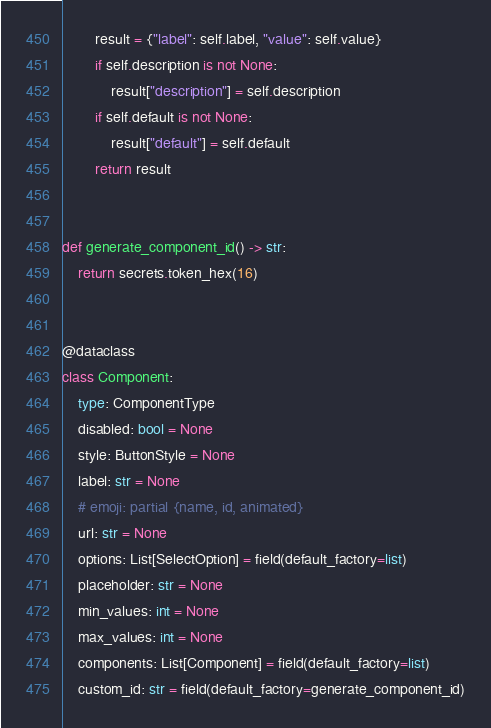Convert code to text. <code><loc_0><loc_0><loc_500><loc_500><_Python_>        result = {"label": self.label, "value": self.value}
        if self.description is not None:
            result["description"] = self.description
        if self.default is not None:
            result["default"] = self.default
        return result


def generate_component_id() -> str:
    return secrets.token_hex(16)


@dataclass
class Component:
    type: ComponentType
    disabled: bool = None
    style: ButtonStyle = None
    label: str = None
    # emoji: partial {name, id, animated}
    url: str = None
    options: List[SelectOption] = field(default_factory=list)
    placeholder: str = None
    min_values: int = None
    max_values: int = None
    components: List[Component] = field(default_factory=list)
    custom_id: str = field(default_factory=generate_component_id)
</code> 